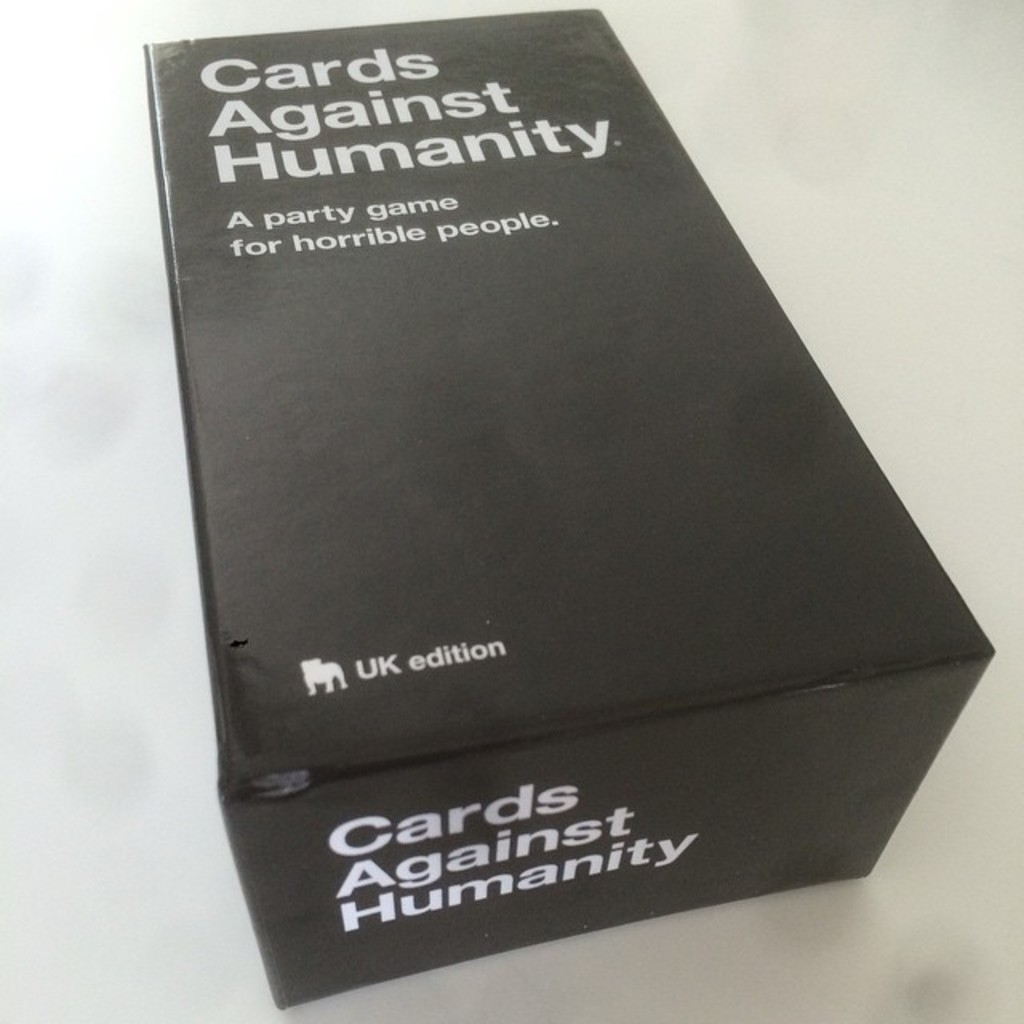What do you see happening in this image? The image displays the UK edition of 'Cards Against Humanity,' prominently featuring its minimalistic black box with white typography. The game is described as 'A party game for horrible people,' suggesting its humorous yet edgy and politically incorrect content, possibly tailored with references unique to the British culture, as indicated by the 'UK edition' text. The simplicity of the design cleverly reflects the straightforward, yet provocative nature of the game, engaging players right from the packaging with expectations of unorthodox and spirited gameplay. 